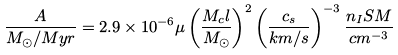<formula> <loc_0><loc_0><loc_500><loc_500>\frac { A } { M _ { \odot } / M y r } = 2 . 9 \times 1 0 ^ { - 6 } \mu \left ( \frac { M _ { c } l } { M _ { \odot } } \right ) ^ { 2 } \left ( \frac { c _ { s } } { k m / s } \right ) ^ { - 3 } \frac { n _ { I } S M } { c m ^ { - 3 } }</formula> 